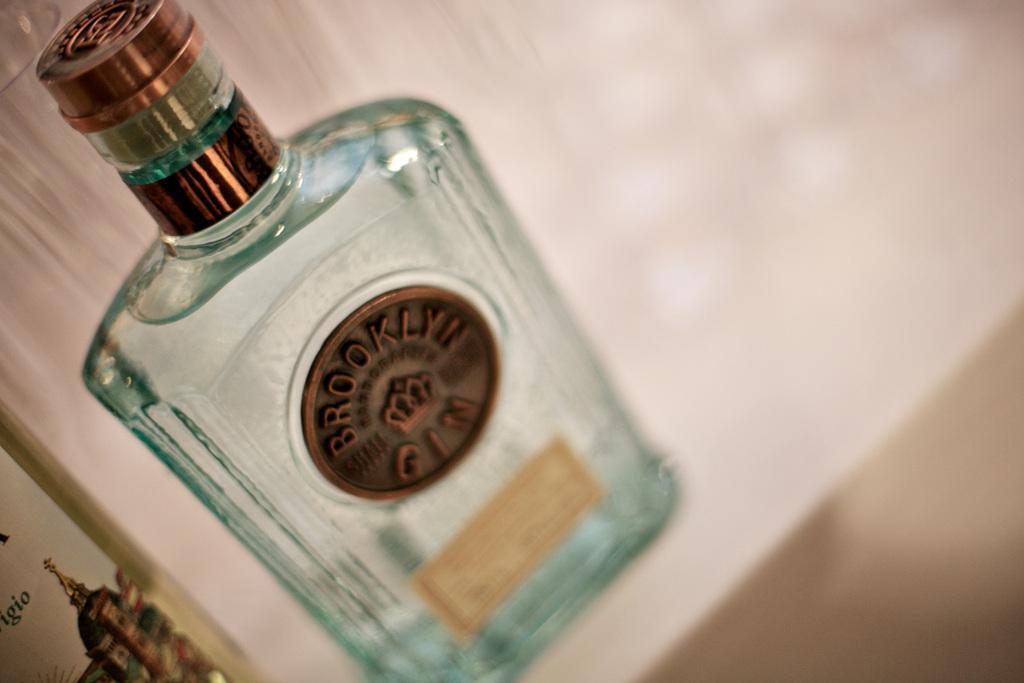Please provide a concise description of this image. There is a bottle with a logo on it written BROOKLYN. 